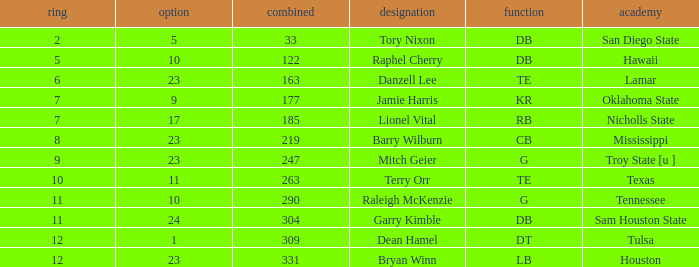How many Picks have a College of hawaii, and an Overall smaller than 122? 0.0. 